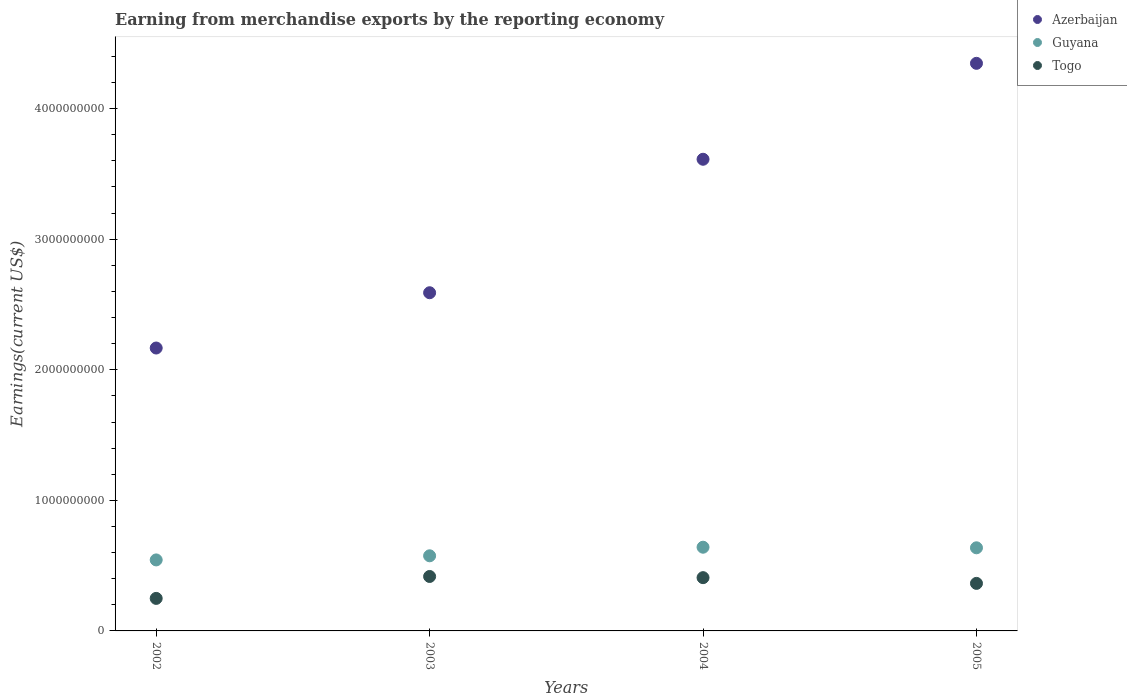What is the amount earned from merchandise exports in Togo in 2003?
Offer a very short reply. 4.17e+08. Across all years, what is the maximum amount earned from merchandise exports in Azerbaijan?
Ensure brevity in your answer.  4.35e+09. Across all years, what is the minimum amount earned from merchandise exports in Guyana?
Provide a short and direct response. 5.44e+08. In which year was the amount earned from merchandise exports in Togo minimum?
Keep it short and to the point. 2002. What is the total amount earned from merchandise exports in Azerbaijan in the graph?
Keep it short and to the point. 1.27e+1. What is the difference between the amount earned from merchandise exports in Azerbaijan in 2004 and that in 2005?
Offer a terse response. -7.35e+08. What is the difference between the amount earned from merchandise exports in Azerbaijan in 2002 and the amount earned from merchandise exports in Guyana in 2003?
Ensure brevity in your answer.  1.59e+09. What is the average amount earned from merchandise exports in Togo per year?
Provide a short and direct response. 3.60e+08. In the year 2002, what is the difference between the amount earned from merchandise exports in Guyana and amount earned from merchandise exports in Togo?
Your answer should be very brief. 2.95e+08. In how many years, is the amount earned from merchandise exports in Togo greater than 200000000 US$?
Make the answer very short. 4. What is the ratio of the amount earned from merchandise exports in Togo in 2004 to that in 2005?
Offer a very short reply. 1.12. Is the difference between the amount earned from merchandise exports in Guyana in 2002 and 2005 greater than the difference between the amount earned from merchandise exports in Togo in 2002 and 2005?
Your answer should be compact. Yes. What is the difference between the highest and the second highest amount earned from merchandise exports in Togo?
Provide a succinct answer. 9.05e+06. What is the difference between the highest and the lowest amount earned from merchandise exports in Guyana?
Provide a succinct answer. 9.73e+07. In how many years, is the amount earned from merchandise exports in Guyana greater than the average amount earned from merchandise exports in Guyana taken over all years?
Ensure brevity in your answer.  2. Is the sum of the amount earned from merchandise exports in Azerbaijan in 2003 and 2005 greater than the maximum amount earned from merchandise exports in Guyana across all years?
Offer a terse response. Yes. Is it the case that in every year, the sum of the amount earned from merchandise exports in Azerbaijan and amount earned from merchandise exports in Togo  is greater than the amount earned from merchandise exports in Guyana?
Offer a terse response. Yes. Does the amount earned from merchandise exports in Azerbaijan monotonically increase over the years?
Make the answer very short. Yes. Is the amount earned from merchandise exports in Togo strictly greater than the amount earned from merchandise exports in Guyana over the years?
Your answer should be very brief. No. How many dotlines are there?
Keep it short and to the point. 3. How many years are there in the graph?
Keep it short and to the point. 4. What is the difference between two consecutive major ticks on the Y-axis?
Provide a succinct answer. 1.00e+09. Does the graph contain any zero values?
Provide a succinct answer. No. Does the graph contain grids?
Give a very brief answer. No. What is the title of the graph?
Your answer should be very brief. Earning from merchandise exports by the reporting economy. What is the label or title of the Y-axis?
Provide a succinct answer. Earnings(current US$). What is the Earnings(current US$) in Azerbaijan in 2002?
Give a very brief answer. 2.17e+09. What is the Earnings(current US$) in Guyana in 2002?
Offer a terse response. 5.44e+08. What is the Earnings(current US$) of Togo in 2002?
Provide a succinct answer. 2.49e+08. What is the Earnings(current US$) in Azerbaijan in 2003?
Offer a very short reply. 2.59e+09. What is the Earnings(current US$) in Guyana in 2003?
Keep it short and to the point. 5.75e+08. What is the Earnings(current US$) of Togo in 2003?
Ensure brevity in your answer.  4.17e+08. What is the Earnings(current US$) of Azerbaijan in 2004?
Offer a terse response. 3.61e+09. What is the Earnings(current US$) of Guyana in 2004?
Keep it short and to the point. 6.41e+08. What is the Earnings(current US$) in Togo in 2004?
Provide a short and direct response. 4.08e+08. What is the Earnings(current US$) in Azerbaijan in 2005?
Provide a short and direct response. 4.35e+09. What is the Earnings(current US$) in Guyana in 2005?
Give a very brief answer. 6.37e+08. What is the Earnings(current US$) in Togo in 2005?
Offer a very short reply. 3.64e+08. Across all years, what is the maximum Earnings(current US$) in Azerbaijan?
Ensure brevity in your answer.  4.35e+09. Across all years, what is the maximum Earnings(current US$) in Guyana?
Make the answer very short. 6.41e+08. Across all years, what is the maximum Earnings(current US$) of Togo?
Provide a short and direct response. 4.17e+08. Across all years, what is the minimum Earnings(current US$) in Azerbaijan?
Provide a succinct answer. 2.17e+09. Across all years, what is the minimum Earnings(current US$) of Guyana?
Make the answer very short. 5.44e+08. Across all years, what is the minimum Earnings(current US$) in Togo?
Your answer should be very brief. 2.49e+08. What is the total Earnings(current US$) of Azerbaijan in the graph?
Ensure brevity in your answer.  1.27e+1. What is the total Earnings(current US$) in Guyana in the graph?
Make the answer very short. 2.40e+09. What is the total Earnings(current US$) in Togo in the graph?
Make the answer very short. 1.44e+09. What is the difference between the Earnings(current US$) of Azerbaijan in 2002 and that in 2003?
Your response must be concise. -4.23e+08. What is the difference between the Earnings(current US$) in Guyana in 2002 and that in 2003?
Ensure brevity in your answer.  -3.15e+07. What is the difference between the Earnings(current US$) of Togo in 2002 and that in 2003?
Provide a short and direct response. -1.68e+08. What is the difference between the Earnings(current US$) in Azerbaijan in 2002 and that in 2004?
Offer a terse response. -1.45e+09. What is the difference between the Earnings(current US$) in Guyana in 2002 and that in 2004?
Offer a very short reply. -9.73e+07. What is the difference between the Earnings(current US$) of Togo in 2002 and that in 2004?
Offer a terse response. -1.59e+08. What is the difference between the Earnings(current US$) of Azerbaijan in 2002 and that in 2005?
Provide a succinct answer. -2.18e+09. What is the difference between the Earnings(current US$) in Guyana in 2002 and that in 2005?
Provide a succinct answer. -9.28e+07. What is the difference between the Earnings(current US$) of Togo in 2002 and that in 2005?
Make the answer very short. -1.15e+08. What is the difference between the Earnings(current US$) in Azerbaijan in 2003 and that in 2004?
Your answer should be compact. -1.02e+09. What is the difference between the Earnings(current US$) of Guyana in 2003 and that in 2004?
Your answer should be very brief. -6.58e+07. What is the difference between the Earnings(current US$) of Togo in 2003 and that in 2004?
Give a very brief answer. 9.05e+06. What is the difference between the Earnings(current US$) of Azerbaijan in 2003 and that in 2005?
Ensure brevity in your answer.  -1.76e+09. What is the difference between the Earnings(current US$) in Guyana in 2003 and that in 2005?
Offer a very short reply. -6.13e+07. What is the difference between the Earnings(current US$) of Togo in 2003 and that in 2005?
Provide a short and direct response. 5.29e+07. What is the difference between the Earnings(current US$) of Azerbaijan in 2004 and that in 2005?
Make the answer very short. -7.35e+08. What is the difference between the Earnings(current US$) of Guyana in 2004 and that in 2005?
Offer a terse response. 4.48e+06. What is the difference between the Earnings(current US$) in Togo in 2004 and that in 2005?
Make the answer very short. 4.38e+07. What is the difference between the Earnings(current US$) of Azerbaijan in 2002 and the Earnings(current US$) of Guyana in 2003?
Offer a very short reply. 1.59e+09. What is the difference between the Earnings(current US$) of Azerbaijan in 2002 and the Earnings(current US$) of Togo in 2003?
Your answer should be very brief. 1.75e+09. What is the difference between the Earnings(current US$) of Guyana in 2002 and the Earnings(current US$) of Togo in 2003?
Your response must be concise. 1.27e+08. What is the difference between the Earnings(current US$) in Azerbaijan in 2002 and the Earnings(current US$) in Guyana in 2004?
Offer a terse response. 1.53e+09. What is the difference between the Earnings(current US$) of Azerbaijan in 2002 and the Earnings(current US$) of Togo in 2004?
Provide a succinct answer. 1.76e+09. What is the difference between the Earnings(current US$) in Guyana in 2002 and the Earnings(current US$) in Togo in 2004?
Give a very brief answer. 1.36e+08. What is the difference between the Earnings(current US$) of Azerbaijan in 2002 and the Earnings(current US$) of Guyana in 2005?
Your answer should be compact. 1.53e+09. What is the difference between the Earnings(current US$) of Azerbaijan in 2002 and the Earnings(current US$) of Togo in 2005?
Your answer should be very brief. 1.80e+09. What is the difference between the Earnings(current US$) in Guyana in 2002 and the Earnings(current US$) in Togo in 2005?
Offer a very short reply. 1.80e+08. What is the difference between the Earnings(current US$) of Azerbaijan in 2003 and the Earnings(current US$) of Guyana in 2004?
Keep it short and to the point. 1.95e+09. What is the difference between the Earnings(current US$) in Azerbaijan in 2003 and the Earnings(current US$) in Togo in 2004?
Provide a succinct answer. 2.18e+09. What is the difference between the Earnings(current US$) in Guyana in 2003 and the Earnings(current US$) in Togo in 2004?
Provide a short and direct response. 1.67e+08. What is the difference between the Earnings(current US$) in Azerbaijan in 2003 and the Earnings(current US$) in Guyana in 2005?
Give a very brief answer. 1.95e+09. What is the difference between the Earnings(current US$) in Azerbaijan in 2003 and the Earnings(current US$) in Togo in 2005?
Offer a terse response. 2.23e+09. What is the difference between the Earnings(current US$) in Guyana in 2003 and the Earnings(current US$) in Togo in 2005?
Your response must be concise. 2.11e+08. What is the difference between the Earnings(current US$) of Azerbaijan in 2004 and the Earnings(current US$) of Guyana in 2005?
Keep it short and to the point. 2.98e+09. What is the difference between the Earnings(current US$) of Azerbaijan in 2004 and the Earnings(current US$) of Togo in 2005?
Keep it short and to the point. 3.25e+09. What is the difference between the Earnings(current US$) in Guyana in 2004 and the Earnings(current US$) in Togo in 2005?
Provide a short and direct response. 2.77e+08. What is the average Earnings(current US$) of Azerbaijan per year?
Your response must be concise. 3.18e+09. What is the average Earnings(current US$) of Guyana per year?
Give a very brief answer. 5.99e+08. What is the average Earnings(current US$) of Togo per year?
Give a very brief answer. 3.60e+08. In the year 2002, what is the difference between the Earnings(current US$) in Azerbaijan and Earnings(current US$) in Guyana?
Offer a very short reply. 1.62e+09. In the year 2002, what is the difference between the Earnings(current US$) of Azerbaijan and Earnings(current US$) of Togo?
Provide a short and direct response. 1.92e+09. In the year 2002, what is the difference between the Earnings(current US$) of Guyana and Earnings(current US$) of Togo?
Your answer should be very brief. 2.95e+08. In the year 2003, what is the difference between the Earnings(current US$) of Azerbaijan and Earnings(current US$) of Guyana?
Make the answer very short. 2.01e+09. In the year 2003, what is the difference between the Earnings(current US$) in Azerbaijan and Earnings(current US$) in Togo?
Make the answer very short. 2.17e+09. In the year 2003, what is the difference between the Earnings(current US$) of Guyana and Earnings(current US$) of Togo?
Your answer should be compact. 1.58e+08. In the year 2004, what is the difference between the Earnings(current US$) in Azerbaijan and Earnings(current US$) in Guyana?
Offer a very short reply. 2.97e+09. In the year 2004, what is the difference between the Earnings(current US$) of Azerbaijan and Earnings(current US$) of Togo?
Your response must be concise. 3.20e+09. In the year 2004, what is the difference between the Earnings(current US$) in Guyana and Earnings(current US$) in Togo?
Keep it short and to the point. 2.33e+08. In the year 2005, what is the difference between the Earnings(current US$) in Azerbaijan and Earnings(current US$) in Guyana?
Give a very brief answer. 3.71e+09. In the year 2005, what is the difference between the Earnings(current US$) of Azerbaijan and Earnings(current US$) of Togo?
Your answer should be very brief. 3.98e+09. In the year 2005, what is the difference between the Earnings(current US$) in Guyana and Earnings(current US$) in Togo?
Offer a very short reply. 2.72e+08. What is the ratio of the Earnings(current US$) of Azerbaijan in 2002 to that in 2003?
Ensure brevity in your answer.  0.84. What is the ratio of the Earnings(current US$) of Guyana in 2002 to that in 2003?
Offer a very short reply. 0.95. What is the ratio of the Earnings(current US$) of Togo in 2002 to that in 2003?
Make the answer very short. 0.6. What is the ratio of the Earnings(current US$) in Azerbaijan in 2002 to that in 2004?
Your answer should be very brief. 0.6. What is the ratio of the Earnings(current US$) of Guyana in 2002 to that in 2004?
Your response must be concise. 0.85. What is the ratio of the Earnings(current US$) of Togo in 2002 to that in 2004?
Your answer should be compact. 0.61. What is the ratio of the Earnings(current US$) in Azerbaijan in 2002 to that in 2005?
Your answer should be compact. 0.5. What is the ratio of the Earnings(current US$) of Guyana in 2002 to that in 2005?
Provide a succinct answer. 0.85. What is the ratio of the Earnings(current US$) of Togo in 2002 to that in 2005?
Keep it short and to the point. 0.68. What is the ratio of the Earnings(current US$) of Azerbaijan in 2003 to that in 2004?
Your answer should be very brief. 0.72. What is the ratio of the Earnings(current US$) of Guyana in 2003 to that in 2004?
Your answer should be very brief. 0.9. What is the ratio of the Earnings(current US$) of Togo in 2003 to that in 2004?
Offer a terse response. 1.02. What is the ratio of the Earnings(current US$) in Azerbaijan in 2003 to that in 2005?
Your answer should be very brief. 0.6. What is the ratio of the Earnings(current US$) of Guyana in 2003 to that in 2005?
Make the answer very short. 0.9. What is the ratio of the Earnings(current US$) of Togo in 2003 to that in 2005?
Keep it short and to the point. 1.15. What is the ratio of the Earnings(current US$) in Azerbaijan in 2004 to that in 2005?
Make the answer very short. 0.83. What is the ratio of the Earnings(current US$) of Togo in 2004 to that in 2005?
Your answer should be compact. 1.12. What is the difference between the highest and the second highest Earnings(current US$) of Azerbaijan?
Provide a short and direct response. 7.35e+08. What is the difference between the highest and the second highest Earnings(current US$) of Guyana?
Keep it short and to the point. 4.48e+06. What is the difference between the highest and the second highest Earnings(current US$) of Togo?
Offer a very short reply. 9.05e+06. What is the difference between the highest and the lowest Earnings(current US$) in Azerbaijan?
Provide a short and direct response. 2.18e+09. What is the difference between the highest and the lowest Earnings(current US$) in Guyana?
Provide a short and direct response. 9.73e+07. What is the difference between the highest and the lowest Earnings(current US$) of Togo?
Give a very brief answer. 1.68e+08. 